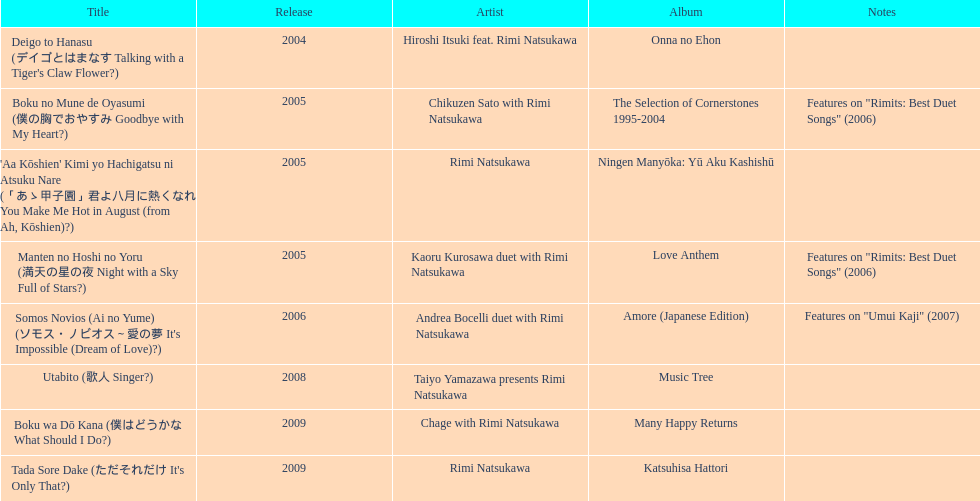How many other appearance did this artist make in 2005? 3. 